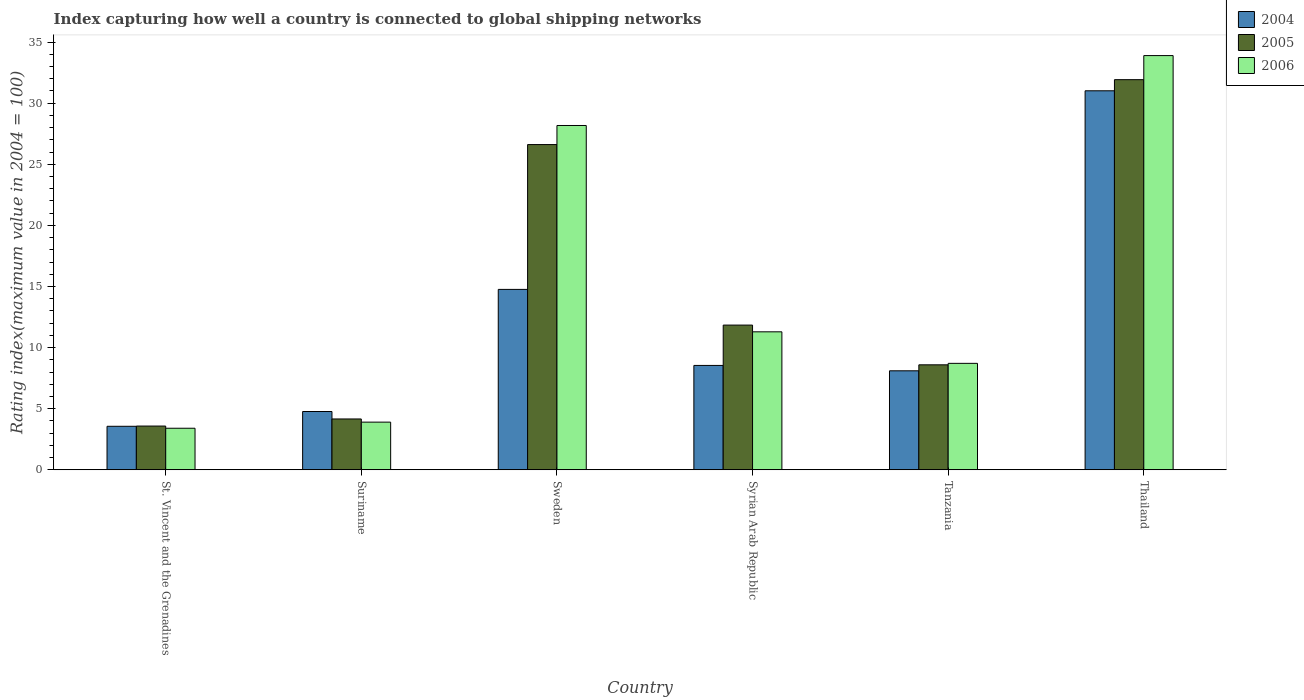How many groups of bars are there?
Keep it short and to the point. 6. Are the number of bars per tick equal to the number of legend labels?
Your response must be concise. Yes. How many bars are there on the 1st tick from the left?
Keep it short and to the point. 3. How many bars are there on the 4th tick from the right?
Your answer should be very brief. 3. What is the label of the 2nd group of bars from the left?
Your answer should be compact. Suriname. In how many cases, is the number of bars for a given country not equal to the number of legend labels?
Your response must be concise. 0. What is the rating index in 2005 in Sweden?
Your answer should be very brief. 26.61. Across all countries, what is the maximum rating index in 2006?
Your answer should be very brief. 33.89. In which country was the rating index in 2004 maximum?
Provide a short and direct response. Thailand. In which country was the rating index in 2004 minimum?
Give a very brief answer. St. Vincent and the Grenadines. What is the total rating index in 2006 in the graph?
Your response must be concise. 89.36. What is the difference between the rating index in 2004 in St. Vincent and the Grenadines and that in Suriname?
Provide a succinct answer. -1.21. What is the difference between the rating index in 2006 in Sweden and the rating index in 2005 in Thailand?
Provide a short and direct response. -3.75. What is the average rating index in 2005 per country?
Offer a terse response. 14.45. What is the difference between the rating index of/in 2004 and rating index of/in 2006 in St. Vincent and the Grenadines?
Keep it short and to the point. 0.16. In how many countries, is the rating index in 2004 greater than 26?
Keep it short and to the point. 1. What is the ratio of the rating index in 2005 in Suriname to that in Tanzania?
Keep it short and to the point. 0.48. What is the difference between the highest and the second highest rating index in 2005?
Offer a terse response. 14.77. What is the difference between the highest and the lowest rating index in 2005?
Your response must be concise. 28.34. Is the sum of the rating index in 2004 in Suriname and Syrian Arab Republic greater than the maximum rating index in 2006 across all countries?
Provide a succinct answer. No. Is it the case that in every country, the sum of the rating index in 2006 and rating index in 2005 is greater than the rating index in 2004?
Offer a terse response. Yes. Are all the bars in the graph horizontal?
Your answer should be very brief. No. How many countries are there in the graph?
Provide a short and direct response. 6. Are the values on the major ticks of Y-axis written in scientific E-notation?
Offer a terse response. No. Does the graph contain any zero values?
Provide a succinct answer. No. What is the title of the graph?
Your answer should be compact. Index capturing how well a country is connected to global shipping networks. Does "1998" appear as one of the legend labels in the graph?
Offer a very short reply. No. What is the label or title of the Y-axis?
Provide a succinct answer. Rating index(maximum value in 2004 = 100). What is the Rating index(maximum value in 2004 = 100) in 2004 in St. Vincent and the Grenadines?
Offer a very short reply. 3.56. What is the Rating index(maximum value in 2004 = 100) of 2005 in St. Vincent and the Grenadines?
Provide a succinct answer. 3.58. What is the Rating index(maximum value in 2004 = 100) of 2004 in Suriname?
Ensure brevity in your answer.  4.77. What is the Rating index(maximum value in 2004 = 100) in 2005 in Suriname?
Give a very brief answer. 4.16. What is the Rating index(maximum value in 2004 = 100) of 2004 in Sweden?
Your response must be concise. 14.76. What is the Rating index(maximum value in 2004 = 100) in 2005 in Sweden?
Your response must be concise. 26.61. What is the Rating index(maximum value in 2004 = 100) in 2006 in Sweden?
Make the answer very short. 28.17. What is the Rating index(maximum value in 2004 = 100) in 2004 in Syrian Arab Republic?
Ensure brevity in your answer.  8.54. What is the Rating index(maximum value in 2004 = 100) in 2005 in Syrian Arab Republic?
Make the answer very short. 11.84. What is the Rating index(maximum value in 2004 = 100) of 2006 in Syrian Arab Republic?
Offer a very short reply. 11.29. What is the Rating index(maximum value in 2004 = 100) in 2005 in Tanzania?
Offer a terse response. 8.59. What is the Rating index(maximum value in 2004 = 100) in 2006 in Tanzania?
Make the answer very short. 8.71. What is the Rating index(maximum value in 2004 = 100) of 2004 in Thailand?
Make the answer very short. 31.01. What is the Rating index(maximum value in 2004 = 100) of 2005 in Thailand?
Keep it short and to the point. 31.92. What is the Rating index(maximum value in 2004 = 100) in 2006 in Thailand?
Your response must be concise. 33.89. Across all countries, what is the maximum Rating index(maximum value in 2004 = 100) of 2004?
Keep it short and to the point. 31.01. Across all countries, what is the maximum Rating index(maximum value in 2004 = 100) of 2005?
Your answer should be very brief. 31.92. Across all countries, what is the maximum Rating index(maximum value in 2004 = 100) in 2006?
Provide a short and direct response. 33.89. Across all countries, what is the minimum Rating index(maximum value in 2004 = 100) of 2004?
Give a very brief answer. 3.56. Across all countries, what is the minimum Rating index(maximum value in 2004 = 100) in 2005?
Your answer should be very brief. 3.58. Across all countries, what is the minimum Rating index(maximum value in 2004 = 100) of 2006?
Make the answer very short. 3.4. What is the total Rating index(maximum value in 2004 = 100) in 2004 in the graph?
Provide a short and direct response. 70.74. What is the total Rating index(maximum value in 2004 = 100) in 2005 in the graph?
Your answer should be compact. 86.7. What is the total Rating index(maximum value in 2004 = 100) in 2006 in the graph?
Your answer should be very brief. 89.36. What is the difference between the Rating index(maximum value in 2004 = 100) in 2004 in St. Vincent and the Grenadines and that in Suriname?
Provide a succinct answer. -1.21. What is the difference between the Rating index(maximum value in 2004 = 100) in 2005 in St. Vincent and the Grenadines and that in Suriname?
Your response must be concise. -0.58. What is the difference between the Rating index(maximum value in 2004 = 100) in 2004 in St. Vincent and the Grenadines and that in Sweden?
Your response must be concise. -11.2. What is the difference between the Rating index(maximum value in 2004 = 100) in 2005 in St. Vincent and the Grenadines and that in Sweden?
Your answer should be very brief. -23.03. What is the difference between the Rating index(maximum value in 2004 = 100) of 2006 in St. Vincent and the Grenadines and that in Sweden?
Keep it short and to the point. -24.77. What is the difference between the Rating index(maximum value in 2004 = 100) of 2004 in St. Vincent and the Grenadines and that in Syrian Arab Republic?
Your response must be concise. -4.98. What is the difference between the Rating index(maximum value in 2004 = 100) in 2005 in St. Vincent and the Grenadines and that in Syrian Arab Republic?
Your answer should be compact. -8.26. What is the difference between the Rating index(maximum value in 2004 = 100) of 2006 in St. Vincent and the Grenadines and that in Syrian Arab Republic?
Give a very brief answer. -7.89. What is the difference between the Rating index(maximum value in 2004 = 100) in 2004 in St. Vincent and the Grenadines and that in Tanzania?
Offer a very short reply. -4.54. What is the difference between the Rating index(maximum value in 2004 = 100) of 2005 in St. Vincent and the Grenadines and that in Tanzania?
Your answer should be very brief. -5.01. What is the difference between the Rating index(maximum value in 2004 = 100) of 2006 in St. Vincent and the Grenadines and that in Tanzania?
Provide a succinct answer. -5.31. What is the difference between the Rating index(maximum value in 2004 = 100) of 2004 in St. Vincent and the Grenadines and that in Thailand?
Your answer should be compact. -27.45. What is the difference between the Rating index(maximum value in 2004 = 100) in 2005 in St. Vincent and the Grenadines and that in Thailand?
Give a very brief answer. -28.34. What is the difference between the Rating index(maximum value in 2004 = 100) in 2006 in St. Vincent and the Grenadines and that in Thailand?
Keep it short and to the point. -30.49. What is the difference between the Rating index(maximum value in 2004 = 100) of 2004 in Suriname and that in Sweden?
Your answer should be compact. -9.99. What is the difference between the Rating index(maximum value in 2004 = 100) in 2005 in Suriname and that in Sweden?
Give a very brief answer. -22.45. What is the difference between the Rating index(maximum value in 2004 = 100) of 2006 in Suriname and that in Sweden?
Your answer should be very brief. -24.27. What is the difference between the Rating index(maximum value in 2004 = 100) of 2004 in Suriname and that in Syrian Arab Republic?
Offer a very short reply. -3.77. What is the difference between the Rating index(maximum value in 2004 = 100) in 2005 in Suriname and that in Syrian Arab Republic?
Give a very brief answer. -7.68. What is the difference between the Rating index(maximum value in 2004 = 100) in 2006 in Suriname and that in Syrian Arab Republic?
Offer a terse response. -7.39. What is the difference between the Rating index(maximum value in 2004 = 100) of 2004 in Suriname and that in Tanzania?
Provide a short and direct response. -3.33. What is the difference between the Rating index(maximum value in 2004 = 100) in 2005 in Suriname and that in Tanzania?
Your answer should be compact. -4.43. What is the difference between the Rating index(maximum value in 2004 = 100) in 2006 in Suriname and that in Tanzania?
Your answer should be very brief. -4.81. What is the difference between the Rating index(maximum value in 2004 = 100) in 2004 in Suriname and that in Thailand?
Offer a terse response. -26.24. What is the difference between the Rating index(maximum value in 2004 = 100) in 2005 in Suriname and that in Thailand?
Give a very brief answer. -27.76. What is the difference between the Rating index(maximum value in 2004 = 100) in 2006 in Suriname and that in Thailand?
Make the answer very short. -29.99. What is the difference between the Rating index(maximum value in 2004 = 100) of 2004 in Sweden and that in Syrian Arab Republic?
Make the answer very short. 6.22. What is the difference between the Rating index(maximum value in 2004 = 100) in 2005 in Sweden and that in Syrian Arab Republic?
Your answer should be compact. 14.77. What is the difference between the Rating index(maximum value in 2004 = 100) of 2006 in Sweden and that in Syrian Arab Republic?
Your answer should be compact. 16.88. What is the difference between the Rating index(maximum value in 2004 = 100) of 2004 in Sweden and that in Tanzania?
Offer a terse response. 6.66. What is the difference between the Rating index(maximum value in 2004 = 100) in 2005 in Sweden and that in Tanzania?
Make the answer very short. 18.02. What is the difference between the Rating index(maximum value in 2004 = 100) in 2006 in Sweden and that in Tanzania?
Give a very brief answer. 19.46. What is the difference between the Rating index(maximum value in 2004 = 100) in 2004 in Sweden and that in Thailand?
Give a very brief answer. -16.25. What is the difference between the Rating index(maximum value in 2004 = 100) of 2005 in Sweden and that in Thailand?
Keep it short and to the point. -5.31. What is the difference between the Rating index(maximum value in 2004 = 100) of 2006 in Sweden and that in Thailand?
Give a very brief answer. -5.72. What is the difference between the Rating index(maximum value in 2004 = 100) of 2004 in Syrian Arab Republic and that in Tanzania?
Your answer should be compact. 0.44. What is the difference between the Rating index(maximum value in 2004 = 100) in 2006 in Syrian Arab Republic and that in Tanzania?
Your answer should be very brief. 2.58. What is the difference between the Rating index(maximum value in 2004 = 100) of 2004 in Syrian Arab Republic and that in Thailand?
Give a very brief answer. -22.47. What is the difference between the Rating index(maximum value in 2004 = 100) of 2005 in Syrian Arab Republic and that in Thailand?
Your answer should be very brief. -20.08. What is the difference between the Rating index(maximum value in 2004 = 100) in 2006 in Syrian Arab Republic and that in Thailand?
Your response must be concise. -22.6. What is the difference between the Rating index(maximum value in 2004 = 100) in 2004 in Tanzania and that in Thailand?
Your answer should be compact. -22.91. What is the difference between the Rating index(maximum value in 2004 = 100) in 2005 in Tanzania and that in Thailand?
Your answer should be very brief. -23.33. What is the difference between the Rating index(maximum value in 2004 = 100) of 2006 in Tanzania and that in Thailand?
Give a very brief answer. -25.18. What is the difference between the Rating index(maximum value in 2004 = 100) of 2004 in St. Vincent and the Grenadines and the Rating index(maximum value in 2004 = 100) of 2005 in Suriname?
Offer a terse response. -0.6. What is the difference between the Rating index(maximum value in 2004 = 100) in 2004 in St. Vincent and the Grenadines and the Rating index(maximum value in 2004 = 100) in 2006 in Suriname?
Your answer should be very brief. -0.34. What is the difference between the Rating index(maximum value in 2004 = 100) of 2005 in St. Vincent and the Grenadines and the Rating index(maximum value in 2004 = 100) of 2006 in Suriname?
Give a very brief answer. -0.32. What is the difference between the Rating index(maximum value in 2004 = 100) in 2004 in St. Vincent and the Grenadines and the Rating index(maximum value in 2004 = 100) in 2005 in Sweden?
Provide a short and direct response. -23.05. What is the difference between the Rating index(maximum value in 2004 = 100) of 2004 in St. Vincent and the Grenadines and the Rating index(maximum value in 2004 = 100) of 2006 in Sweden?
Ensure brevity in your answer.  -24.61. What is the difference between the Rating index(maximum value in 2004 = 100) in 2005 in St. Vincent and the Grenadines and the Rating index(maximum value in 2004 = 100) in 2006 in Sweden?
Your answer should be very brief. -24.59. What is the difference between the Rating index(maximum value in 2004 = 100) in 2004 in St. Vincent and the Grenadines and the Rating index(maximum value in 2004 = 100) in 2005 in Syrian Arab Republic?
Keep it short and to the point. -8.28. What is the difference between the Rating index(maximum value in 2004 = 100) of 2004 in St. Vincent and the Grenadines and the Rating index(maximum value in 2004 = 100) of 2006 in Syrian Arab Republic?
Offer a very short reply. -7.73. What is the difference between the Rating index(maximum value in 2004 = 100) of 2005 in St. Vincent and the Grenadines and the Rating index(maximum value in 2004 = 100) of 2006 in Syrian Arab Republic?
Keep it short and to the point. -7.71. What is the difference between the Rating index(maximum value in 2004 = 100) of 2004 in St. Vincent and the Grenadines and the Rating index(maximum value in 2004 = 100) of 2005 in Tanzania?
Provide a succinct answer. -5.03. What is the difference between the Rating index(maximum value in 2004 = 100) in 2004 in St. Vincent and the Grenadines and the Rating index(maximum value in 2004 = 100) in 2006 in Tanzania?
Keep it short and to the point. -5.15. What is the difference between the Rating index(maximum value in 2004 = 100) in 2005 in St. Vincent and the Grenadines and the Rating index(maximum value in 2004 = 100) in 2006 in Tanzania?
Make the answer very short. -5.13. What is the difference between the Rating index(maximum value in 2004 = 100) in 2004 in St. Vincent and the Grenadines and the Rating index(maximum value in 2004 = 100) in 2005 in Thailand?
Give a very brief answer. -28.36. What is the difference between the Rating index(maximum value in 2004 = 100) in 2004 in St. Vincent and the Grenadines and the Rating index(maximum value in 2004 = 100) in 2006 in Thailand?
Offer a terse response. -30.33. What is the difference between the Rating index(maximum value in 2004 = 100) of 2005 in St. Vincent and the Grenadines and the Rating index(maximum value in 2004 = 100) of 2006 in Thailand?
Your answer should be compact. -30.31. What is the difference between the Rating index(maximum value in 2004 = 100) of 2004 in Suriname and the Rating index(maximum value in 2004 = 100) of 2005 in Sweden?
Provide a succinct answer. -21.84. What is the difference between the Rating index(maximum value in 2004 = 100) in 2004 in Suriname and the Rating index(maximum value in 2004 = 100) in 2006 in Sweden?
Your answer should be very brief. -23.4. What is the difference between the Rating index(maximum value in 2004 = 100) in 2005 in Suriname and the Rating index(maximum value in 2004 = 100) in 2006 in Sweden?
Ensure brevity in your answer.  -24.01. What is the difference between the Rating index(maximum value in 2004 = 100) in 2004 in Suriname and the Rating index(maximum value in 2004 = 100) in 2005 in Syrian Arab Republic?
Keep it short and to the point. -7.07. What is the difference between the Rating index(maximum value in 2004 = 100) of 2004 in Suriname and the Rating index(maximum value in 2004 = 100) of 2006 in Syrian Arab Republic?
Provide a short and direct response. -6.52. What is the difference between the Rating index(maximum value in 2004 = 100) in 2005 in Suriname and the Rating index(maximum value in 2004 = 100) in 2006 in Syrian Arab Republic?
Offer a terse response. -7.13. What is the difference between the Rating index(maximum value in 2004 = 100) in 2004 in Suriname and the Rating index(maximum value in 2004 = 100) in 2005 in Tanzania?
Make the answer very short. -3.82. What is the difference between the Rating index(maximum value in 2004 = 100) in 2004 in Suriname and the Rating index(maximum value in 2004 = 100) in 2006 in Tanzania?
Provide a short and direct response. -3.94. What is the difference between the Rating index(maximum value in 2004 = 100) in 2005 in Suriname and the Rating index(maximum value in 2004 = 100) in 2006 in Tanzania?
Your answer should be compact. -4.55. What is the difference between the Rating index(maximum value in 2004 = 100) of 2004 in Suriname and the Rating index(maximum value in 2004 = 100) of 2005 in Thailand?
Offer a terse response. -27.15. What is the difference between the Rating index(maximum value in 2004 = 100) of 2004 in Suriname and the Rating index(maximum value in 2004 = 100) of 2006 in Thailand?
Provide a succinct answer. -29.12. What is the difference between the Rating index(maximum value in 2004 = 100) in 2005 in Suriname and the Rating index(maximum value in 2004 = 100) in 2006 in Thailand?
Your answer should be very brief. -29.73. What is the difference between the Rating index(maximum value in 2004 = 100) in 2004 in Sweden and the Rating index(maximum value in 2004 = 100) in 2005 in Syrian Arab Republic?
Your response must be concise. 2.92. What is the difference between the Rating index(maximum value in 2004 = 100) of 2004 in Sweden and the Rating index(maximum value in 2004 = 100) of 2006 in Syrian Arab Republic?
Offer a terse response. 3.47. What is the difference between the Rating index(maximum value in 2004 = 100) of 2005 in Sweden and the Rating index(maximum value in 2004 = 100) of 2006 in Syrian Arab Republic?
Your answer should be very brief. 15.32. What is the difference between the Rating index(maximum value in 2004 = 100) in 2004 in Sweden and the Rating index(maximum value in 2004 = 100) in 2005 in Tanzania?
Give a very brief answer. 6.17. What is the difference between the Rating index(maximum value in 2004 = 100) of 2004 in Sweden and the Rating index(maximum value in 2004 = 100) of 2006 in Tanzania?
Provide a succinct answer. 6.05. What is the difference between the Rating index(maximum value in 2004 = 100) in 2005 in Sweden and the Rating index(maximum value in 2004 = 100) in 2006 in Tanzania?
Offer a very short reply. 17.9. What is the difference between the Rating index(maximum value in 2004 = 100) in 2004 in Sweden and the Rating index(maximum value in 2004 = 100) in 2005 in Thailand?
Offer a very short reply. -17.16. What is the difference between the Rating index(maximum value in 2004 = 100) in 2004 in Sweden and the Rating index(maximum value in 2004 = 100) in 2006 in Thailand?
Provide a short and direct response. -19.13. What is the difference between the Rating index(maximum value in 2004 = 100) in 2005 in Sweden and the Rating index(maximum value in 2004 = 100) in 2006 in Thailand?
Your response must be concise. -7.28. What is the difference between the Rating index(maximum value in 2004 = 100) of 2004 in Syrian Arab Republic and the Rating index(maximum value in 2004 = 100) of 2006 in Tanzania?
Give a very brief answer. -0.17. What is the difference between the Rating index(maximum value in 2004 = 100) in 2005 in Syrian Arab Republic and the Rating index(maximum value in 2004 = 100) in 2006 in Tanzania?
Keep it short and to the point. 3.13. What is the difference between the Rating index(maximum value in 2004 = 100) of 2004 in Syrian Arab Republic and the Rating index(maximum value in 2004 = 100) of 2005 in Thailand?
Keep it short and to the point. -23.38. What is the difference between the Rating index(maximum value in 2004 = 100) of 2004 in Syrian Arab Republic and the Rating index(maximum value in 2004 = 100) of 2006 in Thailand?
Keep it short and to the point. -25.35. What is the difference between the Rating index(maximum value in 2004 = 100) of 2005 in Syrian Arab Republic and the Rating index(maximum value in 2004 = 100) of 2006 in Thailand?
Give a very brief answer. -22.05. What is the difference between the Rating index(maximum value in 2004 = 100) of 2004 in Tanzania and the Rating index(maximum value in 2004 = 100) of 2005 in Thailand?
Your response must be concise. -23.82. What is the difference between the Rating index(maximum value in 2004 = 100) in 2004 in Tanzania and the Rating index(maximum value in 2004 = 100) in 2006 in Thailand?
Give a very brief answer. -25.79. What is the difference between the Rating index(maximum value in 2004 = 100) in 2005 in Tanzania and the Rating index(maximum value in 2004 = 100) in 2006 in Thailand?
Your answer should be very brief. -25.3. What is the average Rating index(maximum value in 2004 = 100) of 2004 per country?
Keep it short and to the point. 11.79. What is the average Rating index(maximum value in 2004 = 100) of 2005 per country?
Your answer should be very brief. 14.45. What is the average Rating index(maximum value in 2004 = 100) in 2006 per country?
Your answer should be compact. 14.89. What is the difference between the Rating index(maximum value in 2004 = 100) of 2004 and Rating index(maximum value in 2004 = 100) of 2005 in St. Vincent and the Grenadines?
Offer a very short reply. -0.02. What is the difference between the Rating index(maximum value in 2004 = 100) in 2004 and Rating index(maximum value in 2004 = 100) in 2006 in St. Vincent and the Grenadines?
Your answer should be very brief. 0.16. What is the difference between the Rating index(maximum value in 2004 = 100) of 2005 and Rating index(maximum value in 2004 = 100) of 2006 in St. Vincent and the Grenadines?
Offer a very short reply. 0.18. What is the difference between the Rating index(maximum value in 2004 = 100) of 2004 and Rating index(maximum value in 2004 = 100) of 2005 in Suriname?
Offer a very short reply. 0.61. What is the difference between the Rating index(maximum value in 2004 = 100) in 2004 and Rating index(maximum value in 2004 = 100) in 2006 in Suriname?
Your response must be concise. 0.87. What is the difference between the Rating index(maximum value in 2004 = 100) in 2005 and Rating index(maximum value in 2004 = 100) in 2006 in Suriname?
Your answer should be compact. 0.26. What is the difference between the Rating index(maximum value in 2004 = 100) in 2004 and Rating index(maximum value in 2004 = 100) in 2005 in Sweden?
Give a very brief answer. -11.85. What is the difference between the Rating index(maximum value in 2004 = 100) of 2004 and Rating index(maximum value in 2004 = 100) of 2006 in Sweden?
Your answer should be very brief. -13.41. What is the difference between the Rating index(maximum value in 2004 = 100) in 2005 and Rating index(maximum value in 2004 = 100) in 2006 in Sweden?
Keep it short and to the point. -1.56. What is the difference between the Rating index(maximum value in 2004 = 100) in 2004 and Rating index(maximum value in 2004 = 100) in 2006 in Syrian Arab Republic?
Make the answer very short. -2.75. What is the difference between the Rating index(maximum value in 2004 = 100) in 2005 and Rating index(maximum value in 2004 = 100) in 2006 in Syrian Arab Republic?
Provide a succinct answer. 0.55. What is the difference between the Rating index(maximum value in 2004 = 100) of 2004 and Rating index(maximum value in 2004 = 100) of 2005 in Tanzania?
Your answer should be very brief. -0.49. What is the difference between the Rating index(maximum value in 2004 = 100) in 2004 and Rating index(maximum value in 2004 = 100) in 2006 in Tanzania?
Your answer should be compact. -0.61. What is the difference between the Rating index(maximum value in 2004 = 100) of 2005 and Rating index(maximum value in 2004 = 100) of 2006 in Tanzania?
Give a very brief answer. -0.12. What is the difference between the Rating index(maximum value in 2004 = 100) in 2004 and Rating index(maximum value in 2004 = 100) in 2005 in Thailand?
Provide a short and direct response. -0.91. What is the difference between the Rating index(maximum value in 2004 = 100) of 2004 and Rating index(maximum value in 2004 = 100) of 2006 in Thailand?
Provide a short and direct response. -2.88. What is the difference between the Rating index(maximum value in 2004 = 100) in 2005 and Rating index(maximum value in 2004 = 100) in 2006 in Thailand?
Your response must be concise. -1.97. What is the ratio of the Rating index(maximum value in 2004 = 100) of 2004 in St. Vincent and the Grenadines to that in Suriname?
Your answer should be compact. 0.75. What is the ratio of the Rating index(maximum value in 2004 = 100) in 2005 in St. Vincent and the Grenadines to that in Suriname?
Your response must be concise. 0.86. What is the ratio of the Rating index(maximum value in 2004 = 100) in 2006 in St. Vincent and the Grenadines to that in Suriname?
Offer a very short reply. 0.87. What is the ratio of the Rating index(maximum value in 2004 = 100) of 2004 in St. Vincent and the Grenadines to that in Sweden?
Provide a succinct answer. 0.24. What is the ratio of the Rating index(maximum value in 2004 = 100) of 2005 in St. Vincent and the Grenadines to that in Sweden?
Your response must be concise. 0.13. What is the ratio of the Rating index(maximum value in 2004 = 100) in 2006 in St. Vincent and the Grenadines to that in Sweden?
Provide a succinct answer. 0.12. What is the ratio of the Rating index(maximum value in 2004 = 100) of 2004 in St. Vincent and the Grenadines to that in Syrian Arab Republic?
Your answer should be compact. 0.42. What is the ratio of the Rating index(maximum value in 2004 = 100) in 2005 in St. Vincent and the Grenadines to that in Syrian Arab Republic?
Give a very brief answer. 0.3. What is the ratio of the Rating index(maximum value in 2004 = 100) in 2006 in St. Vincent and the Grenadines to that in Syrian Arab Republic?
Make the answer very short. 0.3. What is the ratio of the Rating index(maximum value in 2004 = 100) in 2004 in St. Vincent and the Grenadines to that in Tanzania?
Your answer should be compact. 0.44. What is the ratio of the Rating index(maximum value in 2004 = 100) of 2005 in St. Vincent and the Grenadines to that in Tanzania?
Make the answer very short. 0.42. What is the ratio of the Rating index(maximum value in 2004 = 100) in 2006 in St. Vincent and the Grenadines to that in Tanzania?
Give a very brief answer. 0.39. What is the ratio of the Rating index(maximum value in 2004 = 100) in 2004 in St. Vincent and the Grenadines to that in Thailand?
Provide a short and direct response. 0.11. What is the ratio of the Rating index(maximum value in 2004 = 100) of 2005 in St. Vincent and the Grenadines to that in Thailand?
Offer a terse response. 0.11. What is the ratio of the Rating index(maximum value in 2004 = 100) in 2006 in St. Vincent and the Grenadines to that in Thailand?
Your response must be concise. 0.1. What is the ratio of the Rating index(maximum value in 2004 = 100) of 2004 in Suriname to that in Sweden?
Provide a succinct answer. 0.32. What is the ratio of the Rating index(maximum value in 2004 = 100) in 2005 in Suriname to that in Sweden?
Provide a short and direct response. 0.16. What is the ratio of the Rating index(maximum value in 2004 = 100) in 2006 in Suriname to that in Sweden?
Give a very brief answer. 0.14. What is the ratio of the Rating index(maximum value in 2004 = 100) in 2004 in Suriname to that in Syrian Arab Republic?
Keep it short and to the point. 0.56. What is the ratio of the Rating index(maximum value in 2004 = 100) in 2005 in Suriname to that in Syrian Arab Republic?
Give a very brief answer. 0.35. What is the ratio of the Rating index(maximum value in 2004 = 100) of 2006 in Suriname to that in Syrian Arab Republic?
Your answer should be very brief. 0.35. What is the ratio of the Rating index(maximum value in 2004 = 100) in 2004 in Suriname to that in Tanzania?
Make the answer very short. 0.59. What is the ratio of the Rating index(maximum value in 2004 = 100) of 2005 in Suriname to that in Tanzania?
Give a very brief answer. 0.48. What is the ratio of the Rating index(maximum value in 2004 = 100) of 2006 in Suriname to that in Tanzania?
Provide a succinct answer. 0.45. What is the ratio of the Rating index(maximum value in 2004 = 100) of 2004 in Suriname to that in Thailand?
Your answer should be very brief. 0.15. What is the ratio of the Rating index(maximum value in 2004 = 100) of 2005 in Suriname to that in Thailand?
Ensure brevity in your answer.  0.13. What is the ratio of the Rating index(maximum value in 2004 = 100) of 2006 in Suriname to that in Thailand?
Your answer should be very brief. 0.12. What is the ratio of the Rating index(maximum value in 2004 = 100) in 2004 in Sweden to that in Syrian Arab Republic?
Your response must be concise. 1.73. What is the ratio of the Rating index(maximum value in 2004 = 100) in 2005 in Sweden to that in Syrian Arab Republic?
Ensure brevity in your answer.  2.25. What is the ratio of the Rating index(maximum value in 2004 = 100) of 2006 in Sweden to that in Syrian Arab Republic?
Ensure brevity in your answer.  2.5. What is the ratio of the Rating index(maximum value in 2004 = 100) of 2004 in Sweden to that in Tanzania?
Ensure brevity in your answer.  1.82. What is the ratio of the Rating index(maximum value in 2004 = 100) in 2005 in Sweden to that in Tanzania?
Provide a succinct answer. 3.1. What is the ratio of the Rating index(maximum value in 2004 = 100) of 2006 in Sweden to that in Tanzania?
Give a very brief answer. 3.23. What is the ratio of the Rating index(maximum value in 2004 = 100) in 2004 in Sweden to that in Thailand?
Provide a short and direct response. 0.48. What is the ratio of the Rating index(maximum value in 2004 = 100) of 2005 in Sweden to that in Thailand?
Provide a succinct answer. 0.83. What is the ratio of the Rating index(maximum value in 2004 = 100) of 2006 in Sweden to that in Thailand?
Offer a terse response. 0.83. What is the ratio of the Rating index(maximum value in 2004 = 100) of 2004 in Syrian Arab Republic to that in Tanzania?
Offer a very short reply. 1.05. What is the ratio of the Rating index(maximum value in 2004 = 100) in 2005 in Syrian Arab Republic to that in Tanzania?
Keep it short and to the point. 1.38. What is the ratio of the Rating index(maximum value in 2004 = 100) in 2006 in Syrian Arab Republic to that in Tanzania?
Your response must be concise. 1.3. What is the ratio of the Rating index(maximum value in 2004 = 100) of 2004 in Syrian Arab Republic to that in Thailand?
Give a very brief answer. 0.28. What is the ratio of the Rating index(maximum value in 2004 = 100) of 2005 in Syrian Arab Republic to that in Thailand?
Provide a succinct answer. 0.37. What is the ratio of the Rating index(maximum value in 2004 = 100) of 2006 in Syrian Arab Republic to that in Thailand?
Your response must be concise. 0.33. What is the ratio of the Rating index(maximum value in 2004 = 100) in 2004 in Tanzania to that in Thailand?
Provide a short and direct response. 0.26. What is the ratio of the Rating index(maximum value in 2004 = 100) in 2005 in Tanzania to that in Thailand?
Offer a very short reply. 0.27. What is the ratio of the Rating index(maximum value in 2004 = 100) of 2006 in Tanzania to that in Thailand?
Offer a terse response. 0.26. What is the difference between the highest and the second highest Rating index(maximum value in 2004 = 100) in 2004?
Offer a very short reply. 16.25. What is the difference between the highest and the second highest Rating index(maximum value in 2004 = 100) of 2005?
Make the answer very short. 5.31. What is the difference between the highest and the second highest Rating index(maximum value in 2004 = 100) in 2006?
Provide a succinct answer. 5.72. What is the difference between the highest and the lowest Rating index(maximum value in 2004 = 100) of 2004?
Offer a terse response. 27.45. What is the difference between the highest and the lowest Rating index(maximum value in 2004 = 100) in 2005?
Make the answer very short. 28.34. What is the difference between the highest and the lowest Rating index(maximum value in 2004 = 100) of 2006?
Offer a terse response. 30.49. 